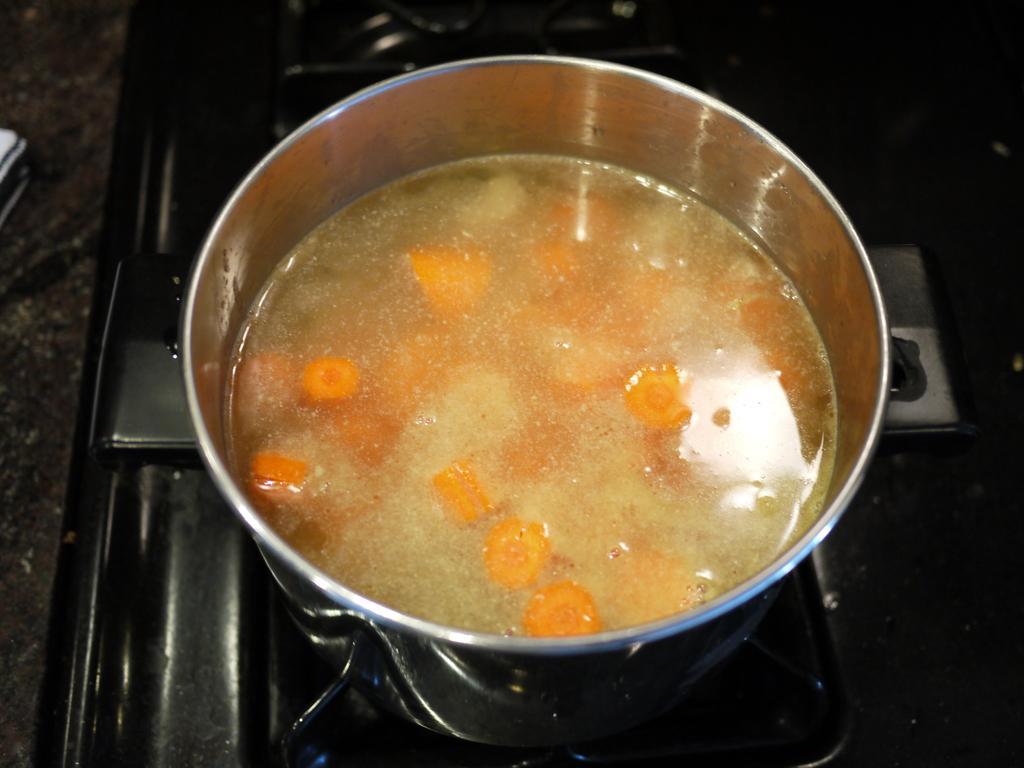Please provide a concise description of this image. There is an utensil in the center of the image, which contains carrots and water in it, which is placed on a stove. 